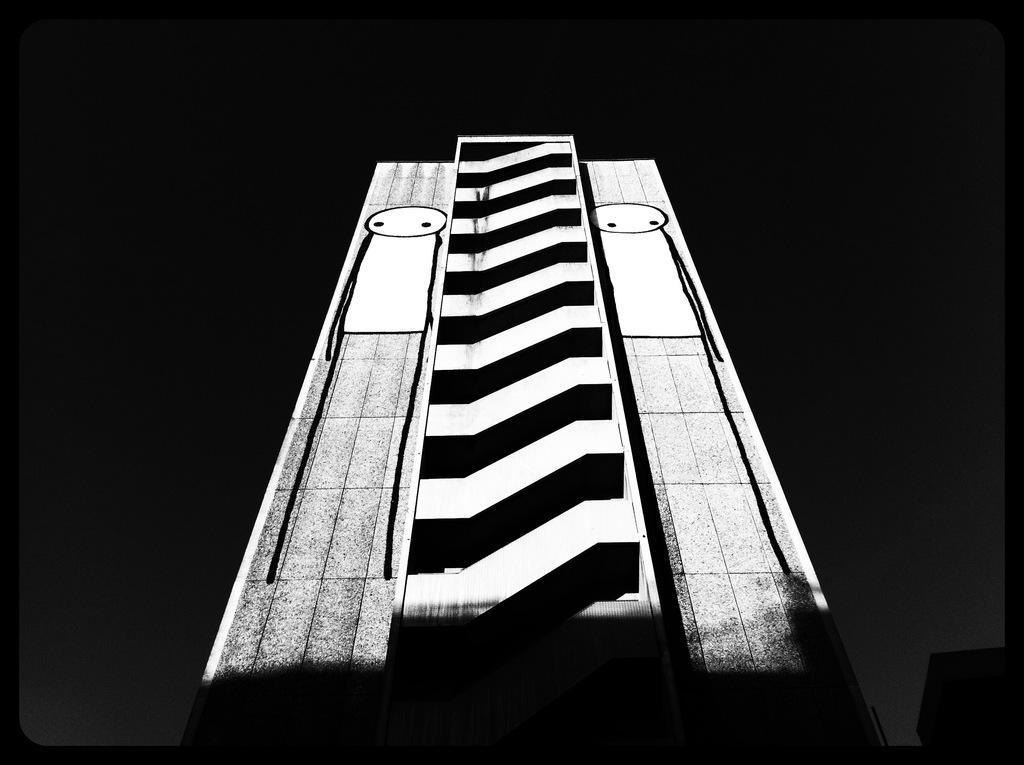In one or two sentences, can you explain what this image depicts? In this image I can see the white and black color painting on the black color surface. 